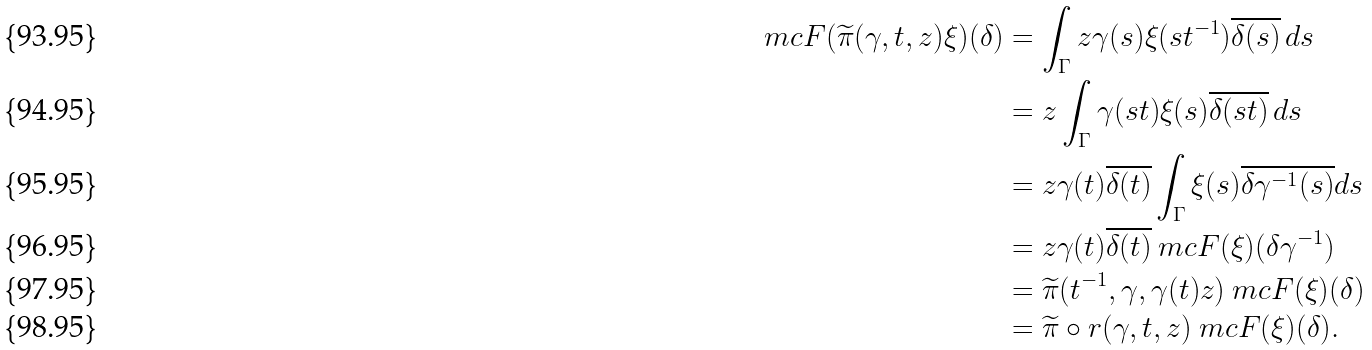<formula> <loc_0><loc_0><loc_500><loc_500>\ m c { F } ( \widetilde { \pi } ( \gamma , t , z ) \xi ) ( \delta ) & = \int _ { \Gamma } z \gamma ( s ) \xi ( s t ^ { - 1 } ) \overline { \delta ( s ) } \, d s \\ & = z \int _ { \Gamma } \gamma ( s t ) \xi ( s ) \overline { \delta ( s t ) } \, d s \\ & = z \gamma ( t ) \overline { \delta ( t ) } \int _ { \Gamma } \xi ( s ) \overline { \delta \gamma ^ { - 1 } ( s ) } d s \\ & = z \gamma ( t ) \overline { \delta ( t ) } \ m c { F } ( \xi ) ( \delta \gamma ^ { - 1 } ) \\ & = \widetilde { \pi } ( t ^ { - 1 } , \gamma , \gamma ( t ) z ) \ m c { F } ( \xi ) ( \delta ) \\ & = \widetilde { \pi } \circ r ( \gamma , t , z ) \ m c { F } ( \xi ) ( \delta ) .</formula> 